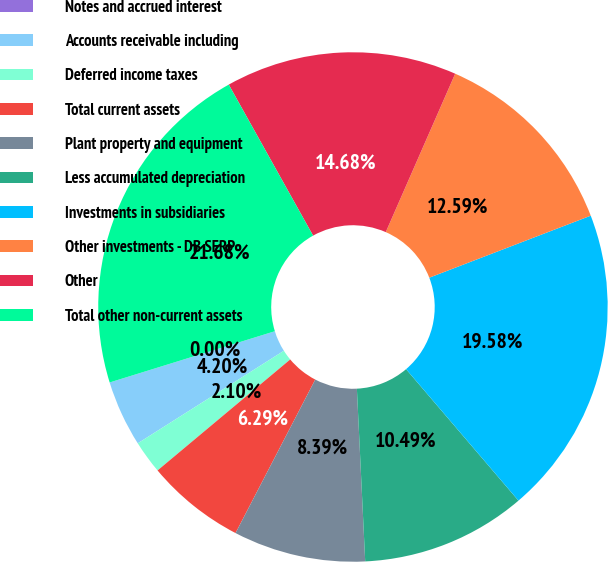Convert chart. <chart><loc_0><loc_0><loc_500><loc_500><pie_chart><fcel>Notes and accrued interest<fcel>Accounts receivable including<fcel>Deferred income taxes<fcel>Total current assets<fcel>Plant property and equipment<fcel>Less accumulated depreciation<fcel>Investments in subsidiaries<fcel>Other investments - DB SERP<fcel>Other<fcel>Total other non-current assets<nl><fcel>0.0%<fcel>4.2%<fcel>2.1%<fcel>6.29%<fcel>8.39%<fcel>10.49%<fcel>19.58%<fcel>12.59%<fcel>14.68%<fcel>21.68%<nl></chart> 